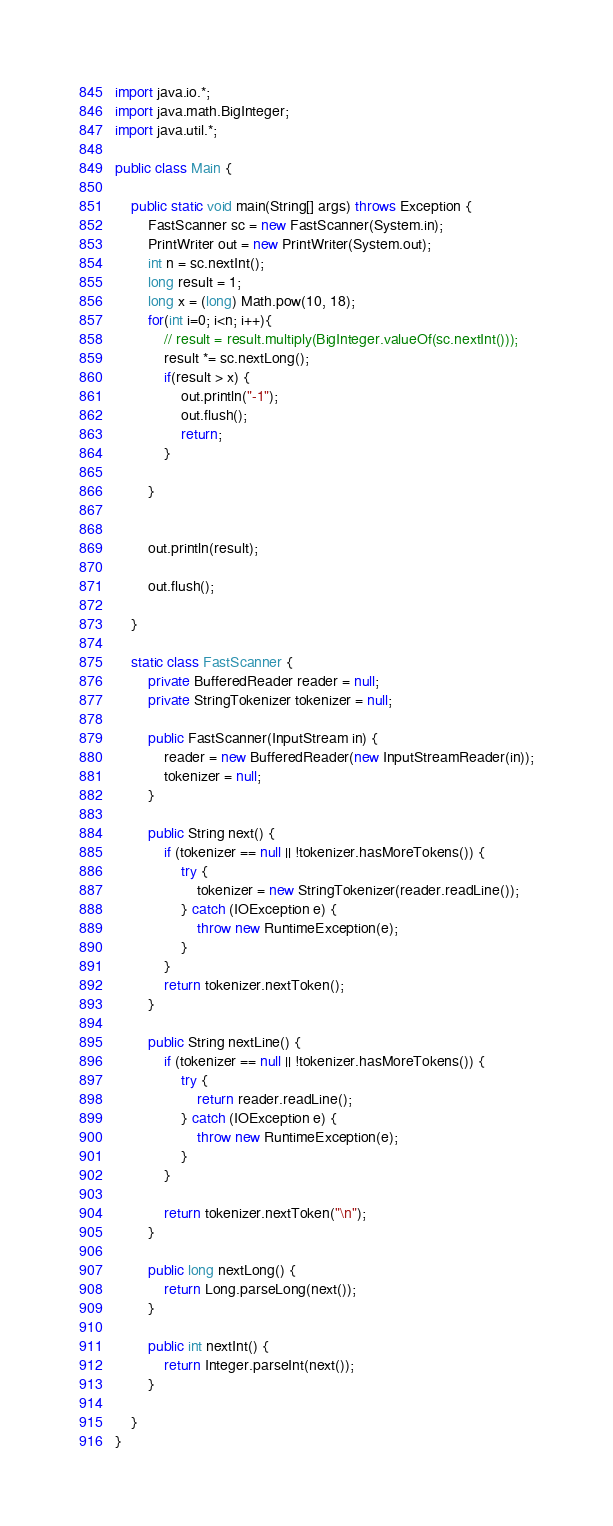Convert code to text. <code><loc_0><loc_0><loc_500><loc_500><_Java_>
import java.io.*;
import java.math.BigInteger;
import java.util.*;

public class Main {

    public static void main(String[] args) throws Exception {
        FastScanner sc = new FastScanner(System.in);
        PrintWriter out = new PrintWriter(System.out);
        int n = sc.nextInt();
        long result = 1;
        long x = (long) Math.pow(10, 18);
        for(int i=0; i<n; i++){
            // result = result.multiply(BigInteger.valueOf(sc.nextInt()));
            result *= sc.nextLong();
            if(result > x) {
                out.println("-1");
                out.flush();
                return;
            }

        }
        

        out.println(result);

        out.flush();

    }

    static class FastScanner {
        private BufferedReader reader = null;
        private StringTokenizer tokenizer = null;

        public FastScanner(InputStream in) {
            reader = new BufferedReader(new InputStreamReader(in));
            tokenizer = null;
        }

        public String next() {
            if (tokenizer == null || !tokenizer.hasMoreTokens()) {
                try {
                    tokenizer = new StringTokenizer(reader.readLine());
                } catch (IOException e) {
                    throw new RuntimeException(e);
                }
            }
            return tokenizer.nextToken();
        }

        public String nextLine() {
            if (tokenizer == null || !tokenizer.hasMoreTokens()) {
                try {
                    return reader.readLine();
                } catch (IOException e) {
                    throw new RuntimeException(e);
                }
            }

            return tokenizer.nextToken("\n");
        }

        public long nextLong() {
            return Long.parseLong(next());
        }

        public int nextInt() {
            return Integer.parseInt(next());
        }

    }
}</code> 